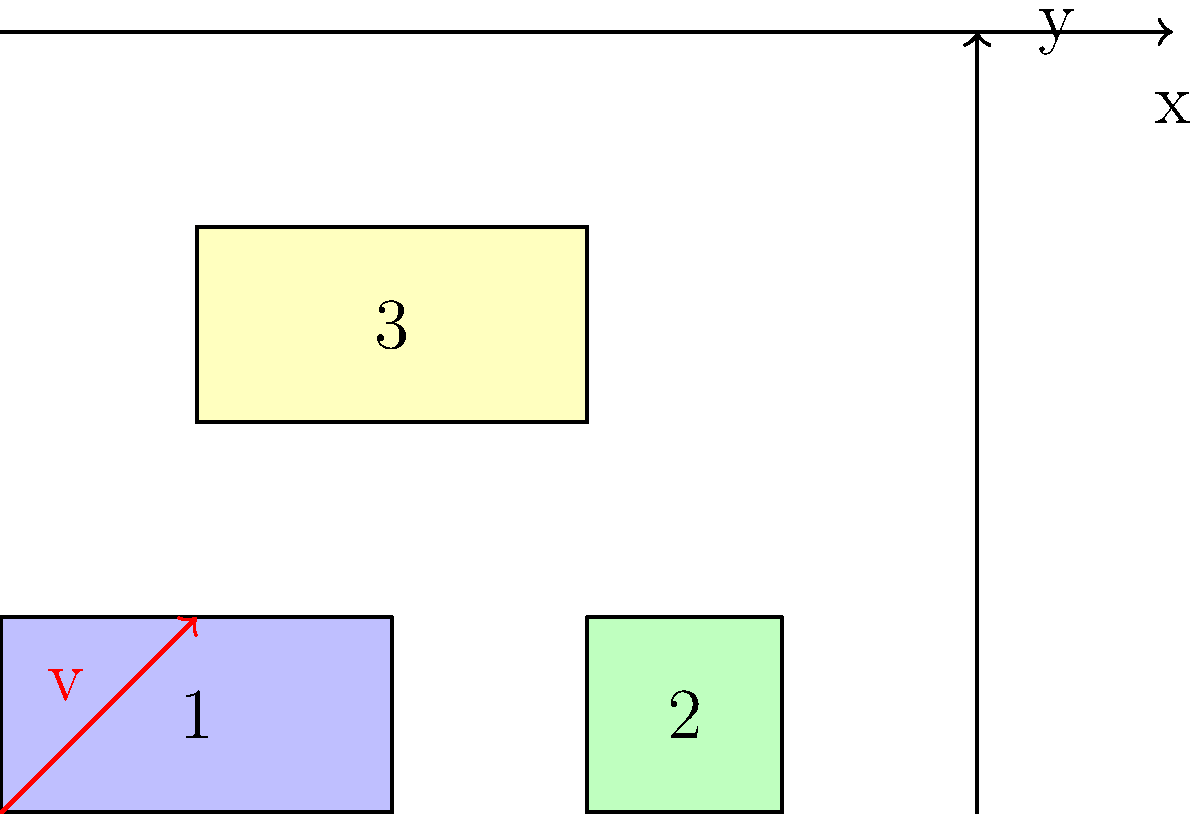As a property developer optimizing land use efficiency, you need to translate three building footprints on a plot. Given the current layout shown in the diagram, where buildings 1, 2, and 3 are represented by blue, green, and yellow rectangles respectively, what would be the new coordinates of the bottom-left corner of building 3 after applying the translation vector $v = (1, 1)$ to all buildings simultaneously? To solve this problem, we'll follow these steps:

1. Identify the current coordinates of the bottom-left corner of building 3:
   The bottom-left corner of building 3 is at $(1, 2)$.

2. Understand the translation vector:
   The translation vector $v = (1, 1)$ means we need to add 1 to both the x and y coordinates.

3. Apply the translation:
   New x-coordinate = Current x-coordinate + x-component of translation vector
   New y-coordinate = Current y-coordinate + y-component of translation vector

   New x-coordinate = $1 + 1 = 2$
   New y-coordinate = $2 + 1 = 3$

4. Express the new coordinates as an ordered pair:
   The new coordinates of the bottom-left corner of building 3 are $(2, 3)$.

This translation optimizes land use by moving all buildings simultaneously, maintaining their relative positions while utilizing previously unoccupied space.
Answer: $(2, 3)$ 